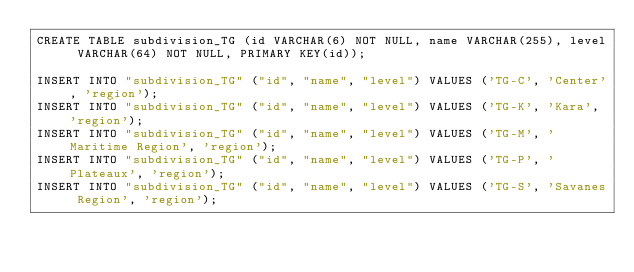<code> <loc_0><loc_0><loc_500><loc_500><_SQL_>CREATE TABLE subdivision_TG (id VARCHAR(6) NOT NULL, name VARCHAR(255), level VARCHAR(64) NOT NULL, PRIMARY KEY(id));

INSERT INTO "subdivision_TG" ("id", "name", "level") VALUES ('TG-C', 'Center', 'region');
INSERT INTO "subdivision_TG" ("id", "name", "level") VALUES ('TG-K', 'Kara', 'region');
INSERT INTO "subdivision_TG" ("id", "name", "level") VALUES ('TG-M', 'Maritime Region', 'region');
INSERT INTO "subdivision_TG" ("id", "name", "level") VALUES ('TG-P', 'Plateaux', 'region');
INSERT INTO "subdivision_TG" ("id", "name", "level") VALUES ('TG-S', 'Savanes Region', 'region');
</code> 